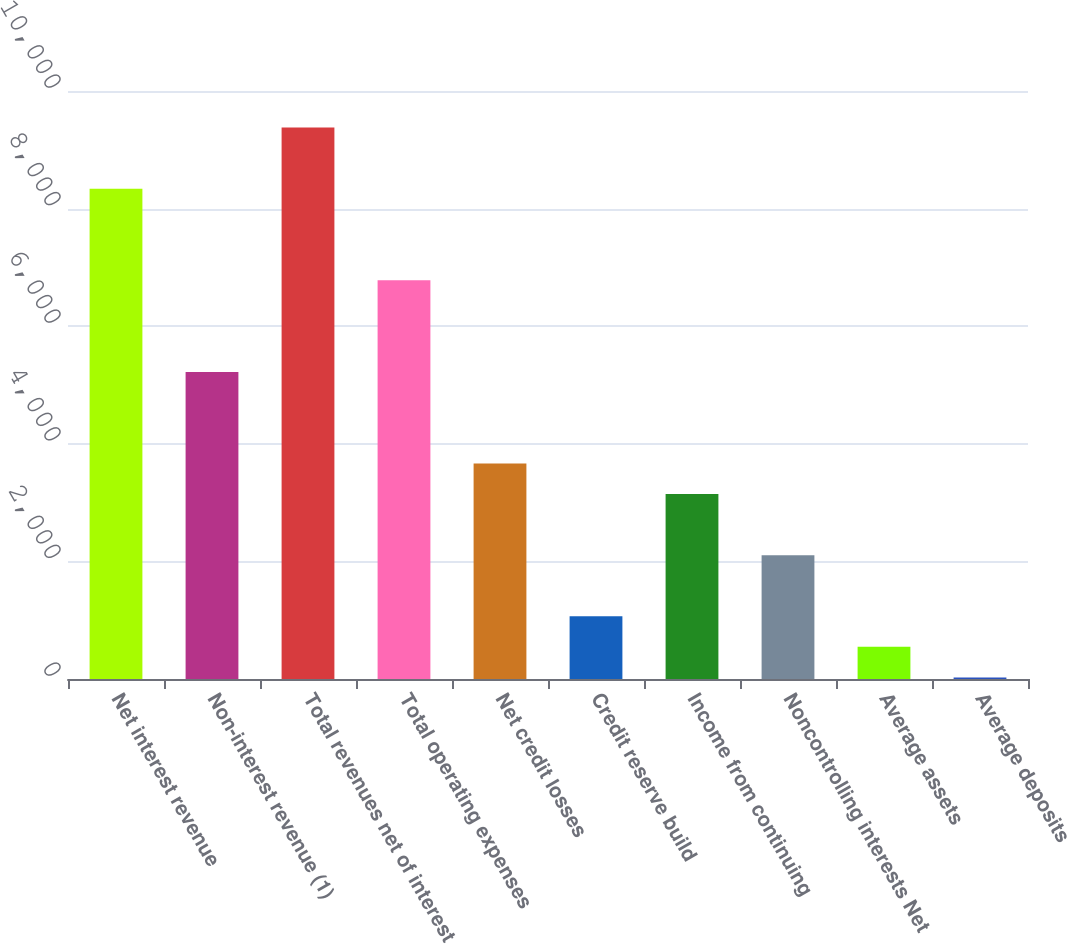<chart> <loc_0><loc_0><loc_500><loc_500><bar_chart><fcel>Net interest revenue<fcel>Non-interest revenue (1)<fcel>Total revenues net of interest<fcel>Total operating expenses<fcel>Net credit losses<fcel>Credit reserve build<fcel>Income from continuing<fcel>Noncontrolling interests Net<fcel>Average assets<fcel>Average deposits<nl><fcel>8338.76<fcel>5222<fcel>9377.68<fcel>6780.38<fcel>3663.62<fcel>1066.32<fcel>3144.16<fcel>2105.24<fcel>546.86<fcel>27.4<nl></chart> 